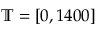<formula> <loc_0><loc_0><loc_500><loc_500>\mathbb { T } = [ 0 , 1 4 0 0 ]</formula> 